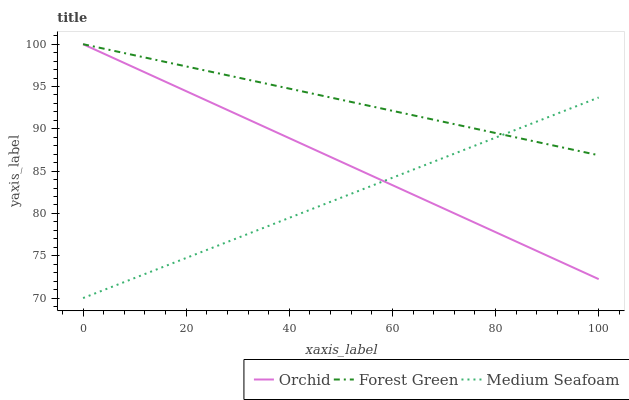Does Medium Seafoam have the minimum area under the curve?
Answer yes or no. Yes. Does Forest Green have the maximum area under the curve?
Answer yes or no. Yes. Does Orchid have the minimum area under the curve?
Answer yes or no. No. Does Orchid have the maximum area under the curve?
Answer yes or no. No. Is Orchid the smoothest?
Answer yes or no. Yes. Is Medium Seafoam the roughest?
Answer yes or no. Yes. Is Medium Seafoam the smoothest?
Answer yes or no. No. Is Orchid the roughest?
Answer yes or no. No. Does Medium Seafoam have the lowest value?
Answer yes or no. Yes. Does Orchid have the lowest value?
Answer yes or no. No. Does Orchid have the highest value?
Answer yes or no. Yes. Does Medium Seafoam have the highest value?
Answer yes or no. No. Does Orchid intersect Forest Green?
Answer yes or no. Yes. Is Orchid less than Forest Green?
Answer yes or no. No. Is Orchid greater than Forest Green?
Answer yes or no. No. 